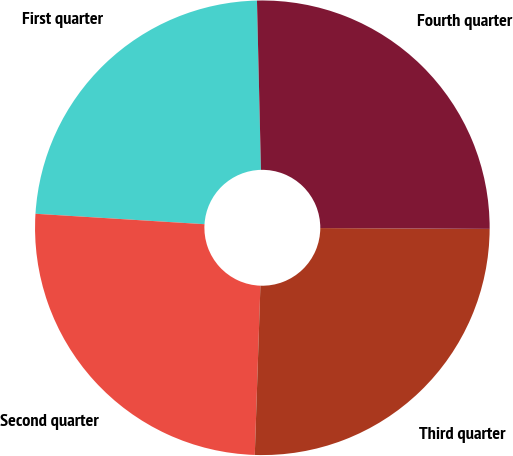Convert chart to OTSL. <chart><loc_0><loc_0><loc_500><loc_500><pie_chart><fcel>First quarter<fcel>Second quarter<fcel>Third quarter<fcel>Fourth quarter<nl><fcel>23.64%<fcel>25.45%<fcel>25.45%<fcel>25.45%<nl></chart> 